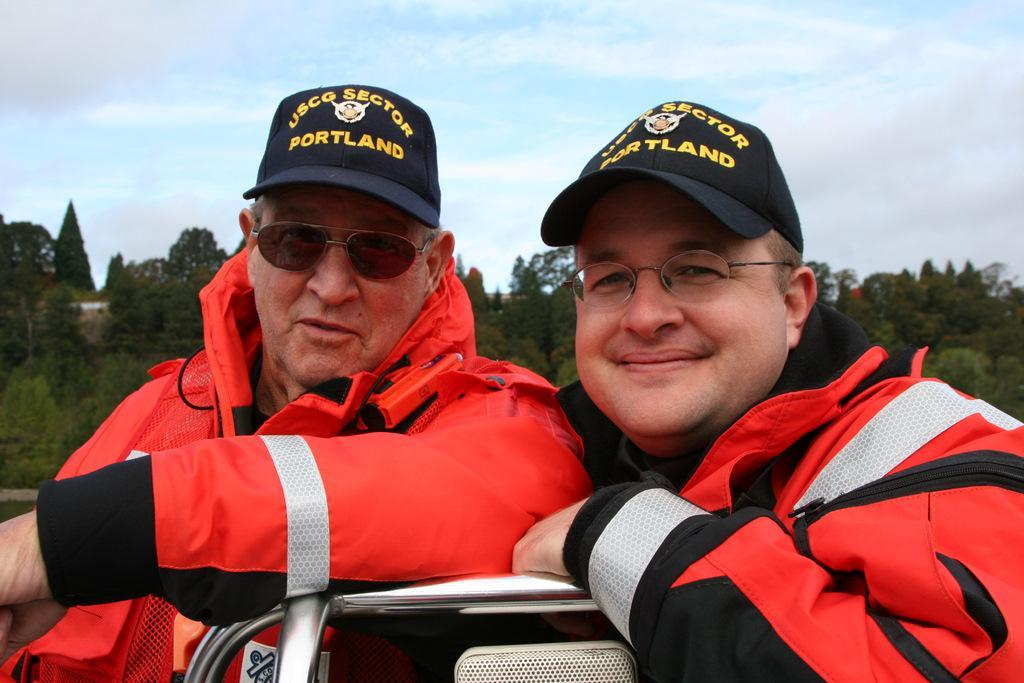How many people are in the image? There are two persons in the image. What are the persons wearing on their faces? Both persons are wearing glasses. What type of headwear are the persons wearing? Both persons are wearing caps. What can be seen in the background of the image? There are trees and the sky visible in the background of the image. What is the current temperature in the image? The provided facts do not mention any information about the temperature, so it cannot be determined from the image. 